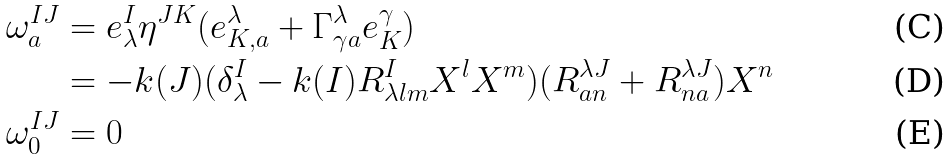Convert formula to latex. <formula><loc_0><loc_0><loc_500><loc_500>\omega ^ { I J } _ { a } & = e ^ { I } _ { \lambda } \eta ^ { J K } ( e ^ { \lambda } _ { K , a } + \Gamma ^ { \lambda } _ { \gamma a } e ^ { \gamma } _ { K } ) \\ & = - k ( J ) ( \delta ^ { I } _ { \lambda } - k ( I ) R _ { \lambda l m } ^ { I } X ^ { l } X ^ { m } ) ( R _ { a n } ^ { \lambda J } + R _ { n a } ^ { \lambda J } ) X ^ { n } \\ \omega ^ { I J } _ { 0 } & = 0</formula> 